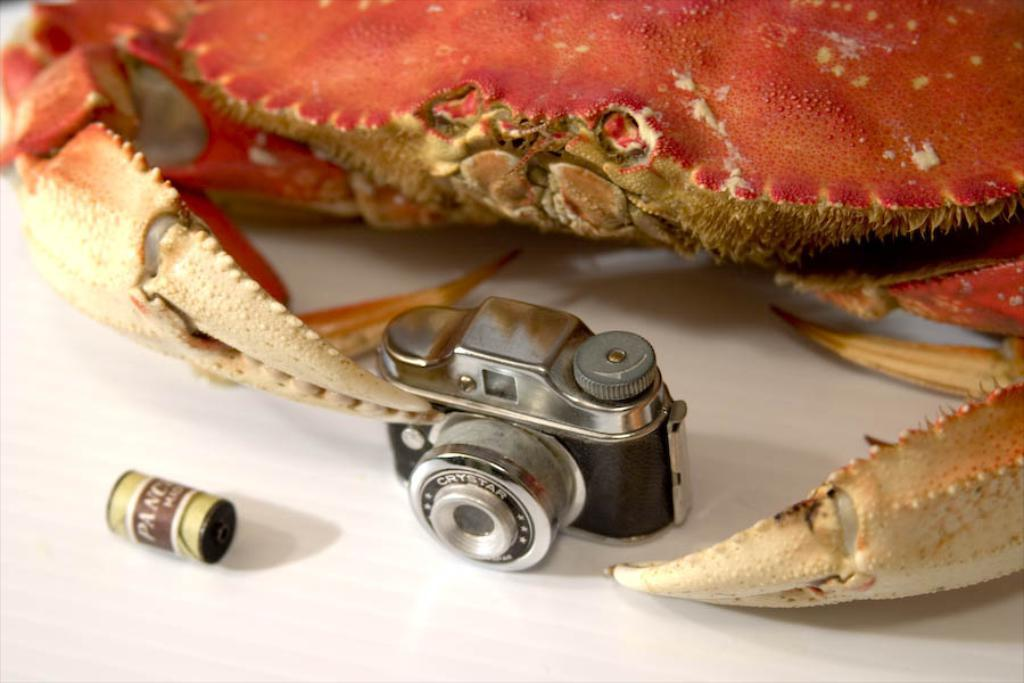What type of animal is in the image? There is a crab in the image. What device is also present in the image? There is a camera in the image. Can you describe the unspecified object in the image? Unfortunately, the facts provided do not give any details about the unspecified object. What is the color of the surface on which the objects are placed? The objects are on a white surface. What type of plants can be seen growing on the road in the image? There is no road or plants present in the image; it features a crab, a camera, and an unspecified object on a white surface. 